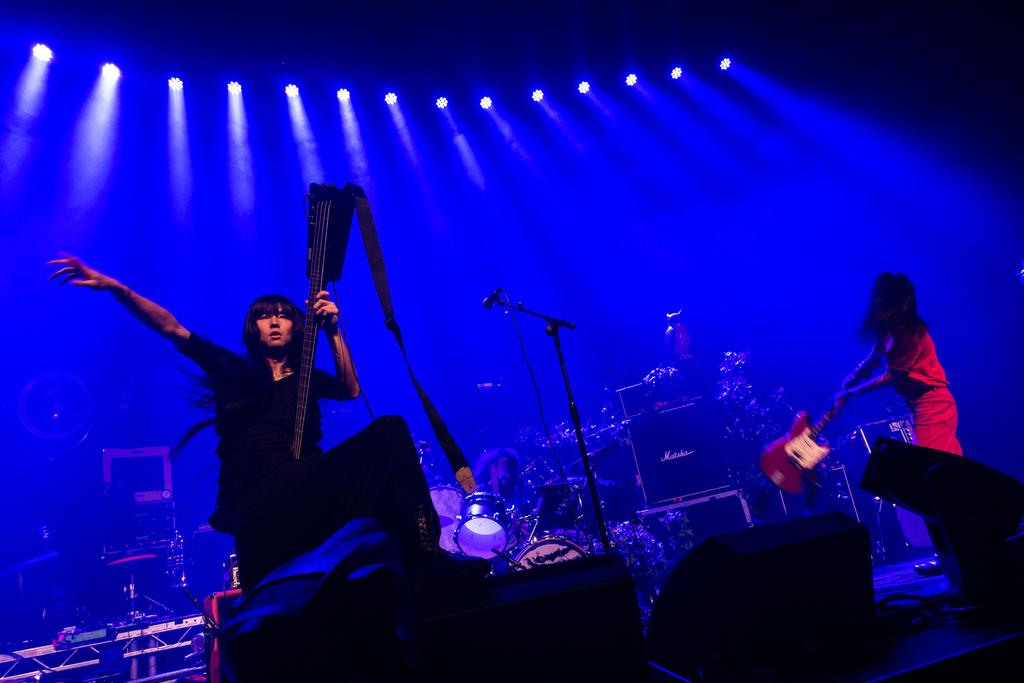How many women are in the image? There are two women in the image. What are the women carrying in the image? The women are carrying guitars. What is another person doing in the image? There is a person playing drums in the image. What can be seen near the musicians in the image? There is a mic stand and lights in the image. What other musical instruments can be seen in the image? There are other musical instruments in the image. What advice does the person playing drums give to the women in the image? There is no indication in the image that the person playing drums is giving advice to the women. 